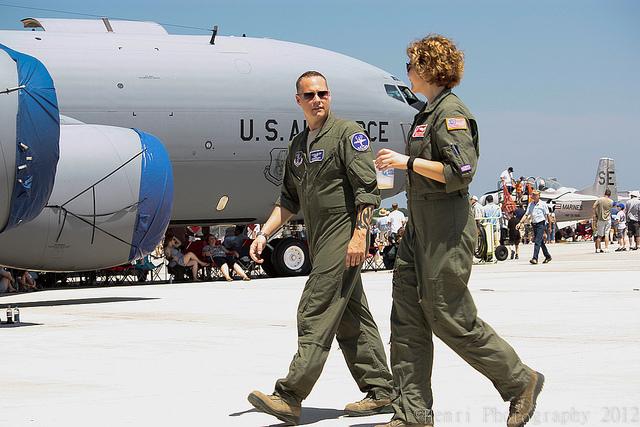What department of the military is this?
Write a very short answer. Air force. Are there any helicopters in this picture?
Quick response, please. No. What does it say on the plane?
Write a very short answer. Us air force. 